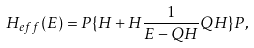<formula> <loc_0><loc_0><loc_500><loc_500>H _ { e f f } ( E ) = P \{ H + H \frac { 1 } { E - Q H } Q H \} P ,</formula> 